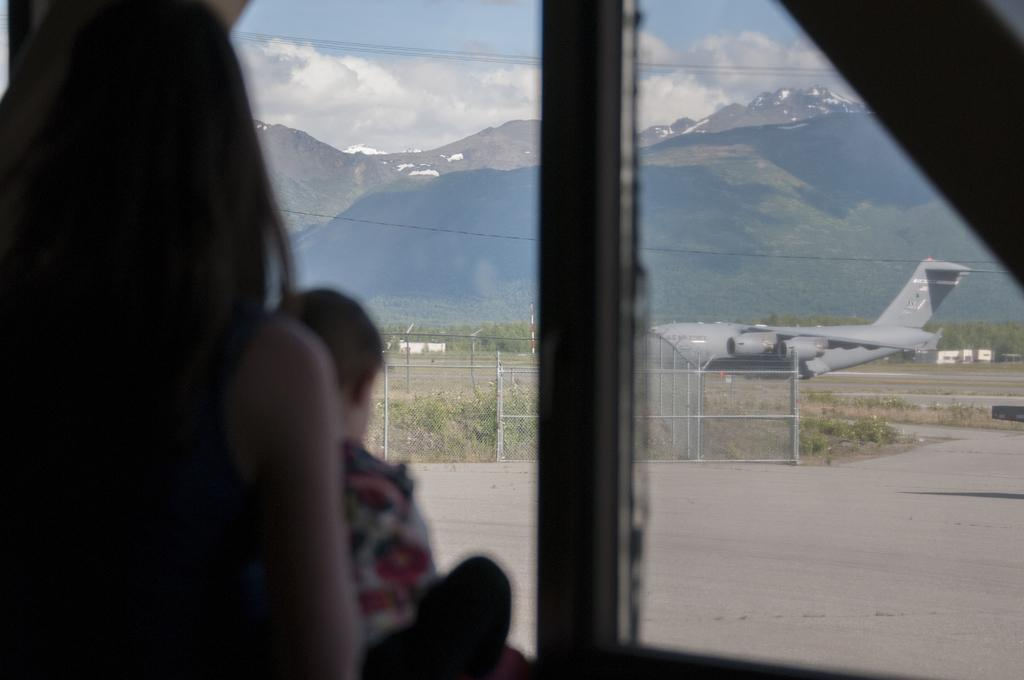What can be seen on the left side of the image? There are people on the left side of the image. What is present in the image that allows for a view of the outside? There is a window in the image. What can be seen through the window glass? An aeroplane, a fence, hills, wires, and the sky can be seen through the window glass. How many frogs are visible on the left side of the image? There are no frogs visible on the left side of the image. What type of power source can be seen through the window glass? There is no power source visible through the window glass in the image. 